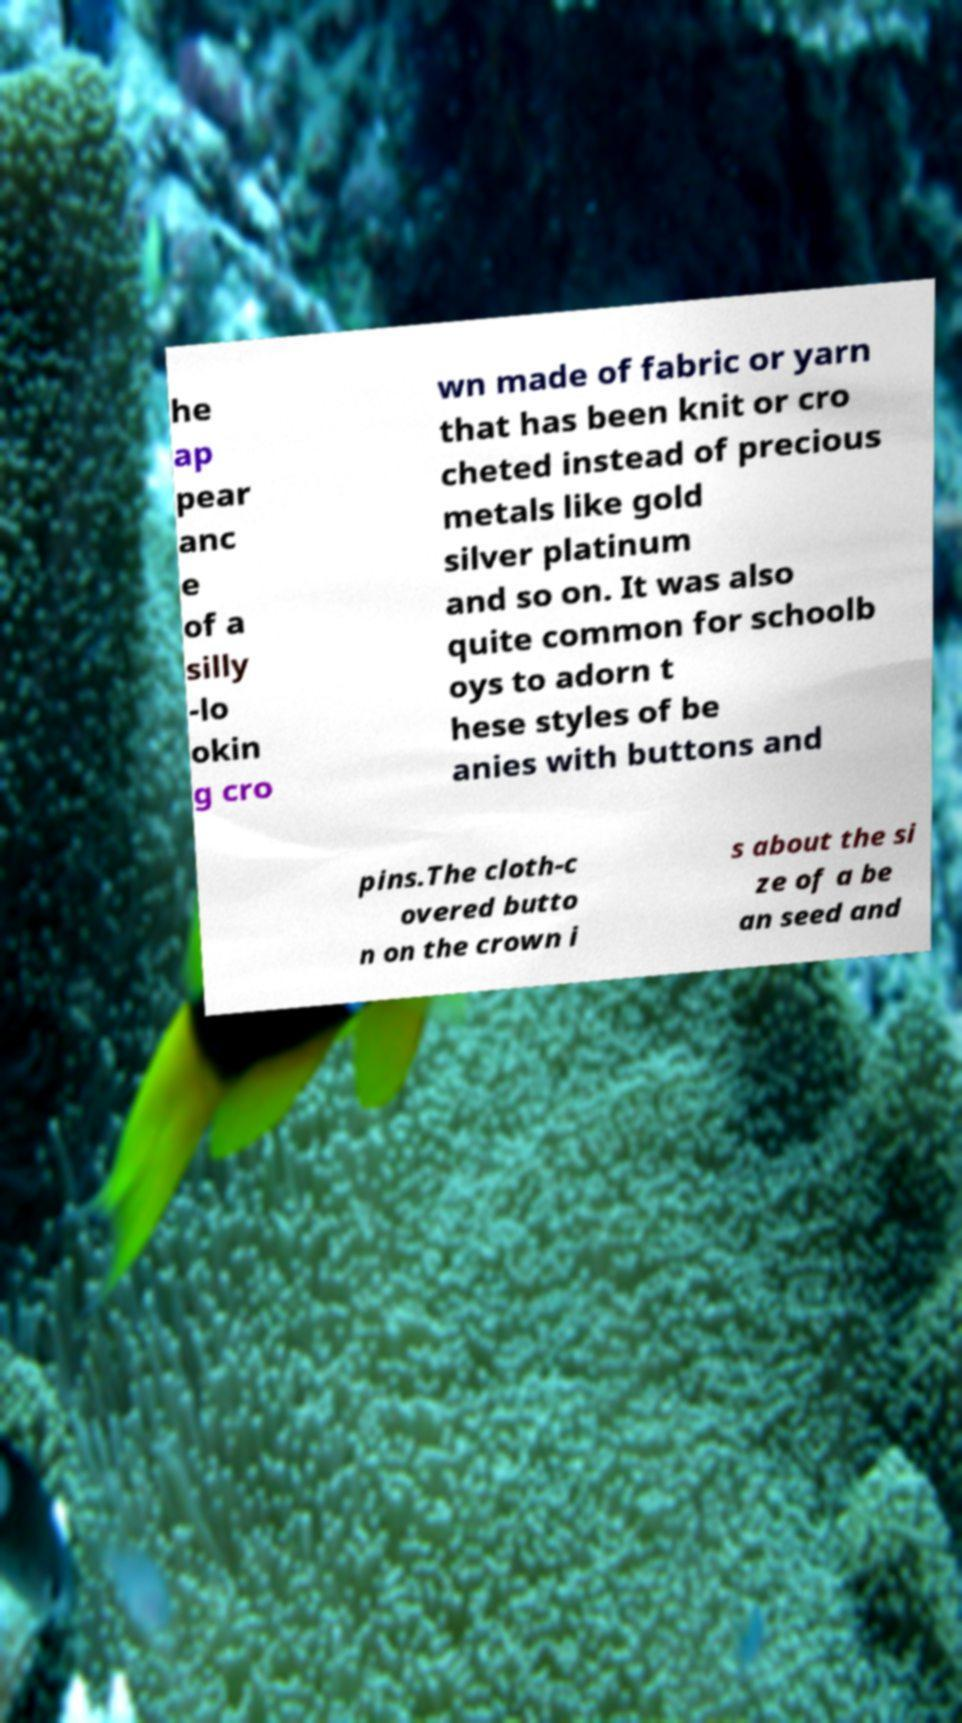Can you accurately transcribe the text from the provided image for me? he ap pear anc e of a silly -lo okin g cro wn made of fabric or yarn that has been knit or cro cheted instead of precious metals like gold silver platinum and so on. It was also quite common for schoolb oys to adorn t hese styles of be anies with buttons and pins.The cloth-c overed butto n on the crown i s about the si ze of a be an seed and 